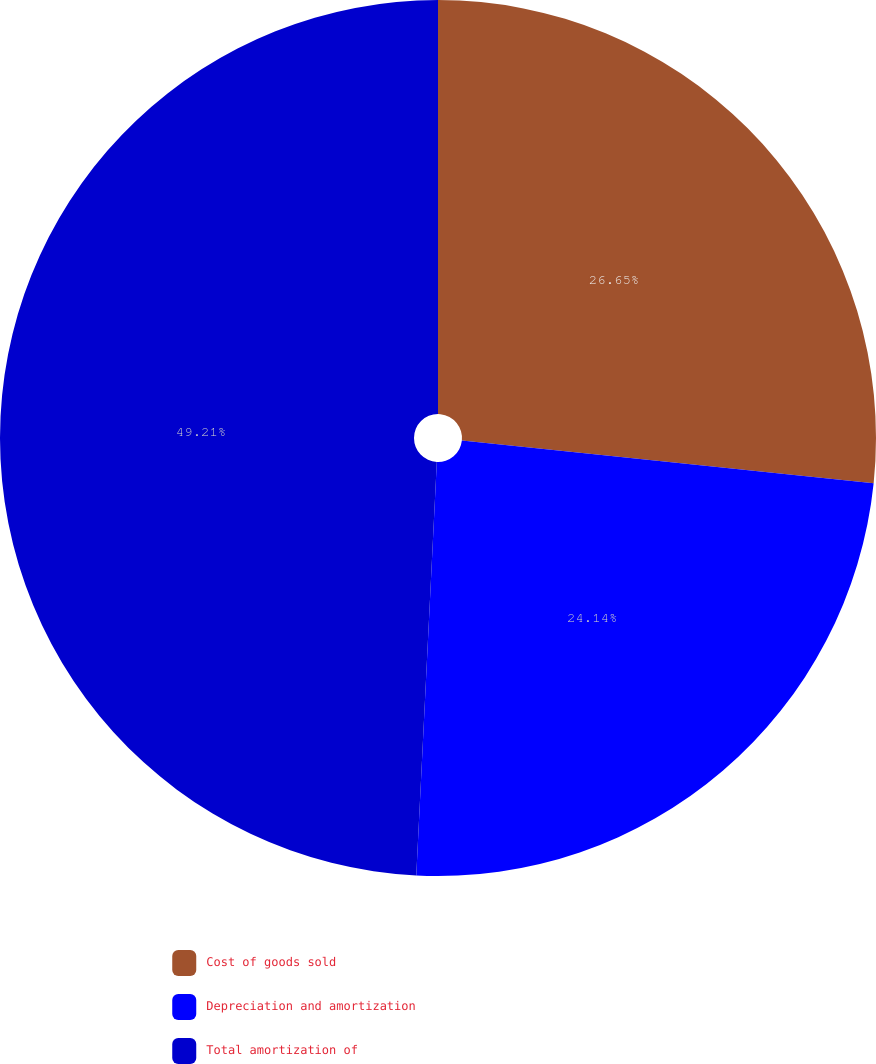Convert chart to OTSL. <chart><loc_0><loc_0><loc_500><loc_500><pie_chart><fcel>Cost of goods sold<fcel>Depreciation and amortization<fcel>Total amortization of<nl><fcel>26.65%<fcel>24.14%<fcel>49.21%<nl></chart> 